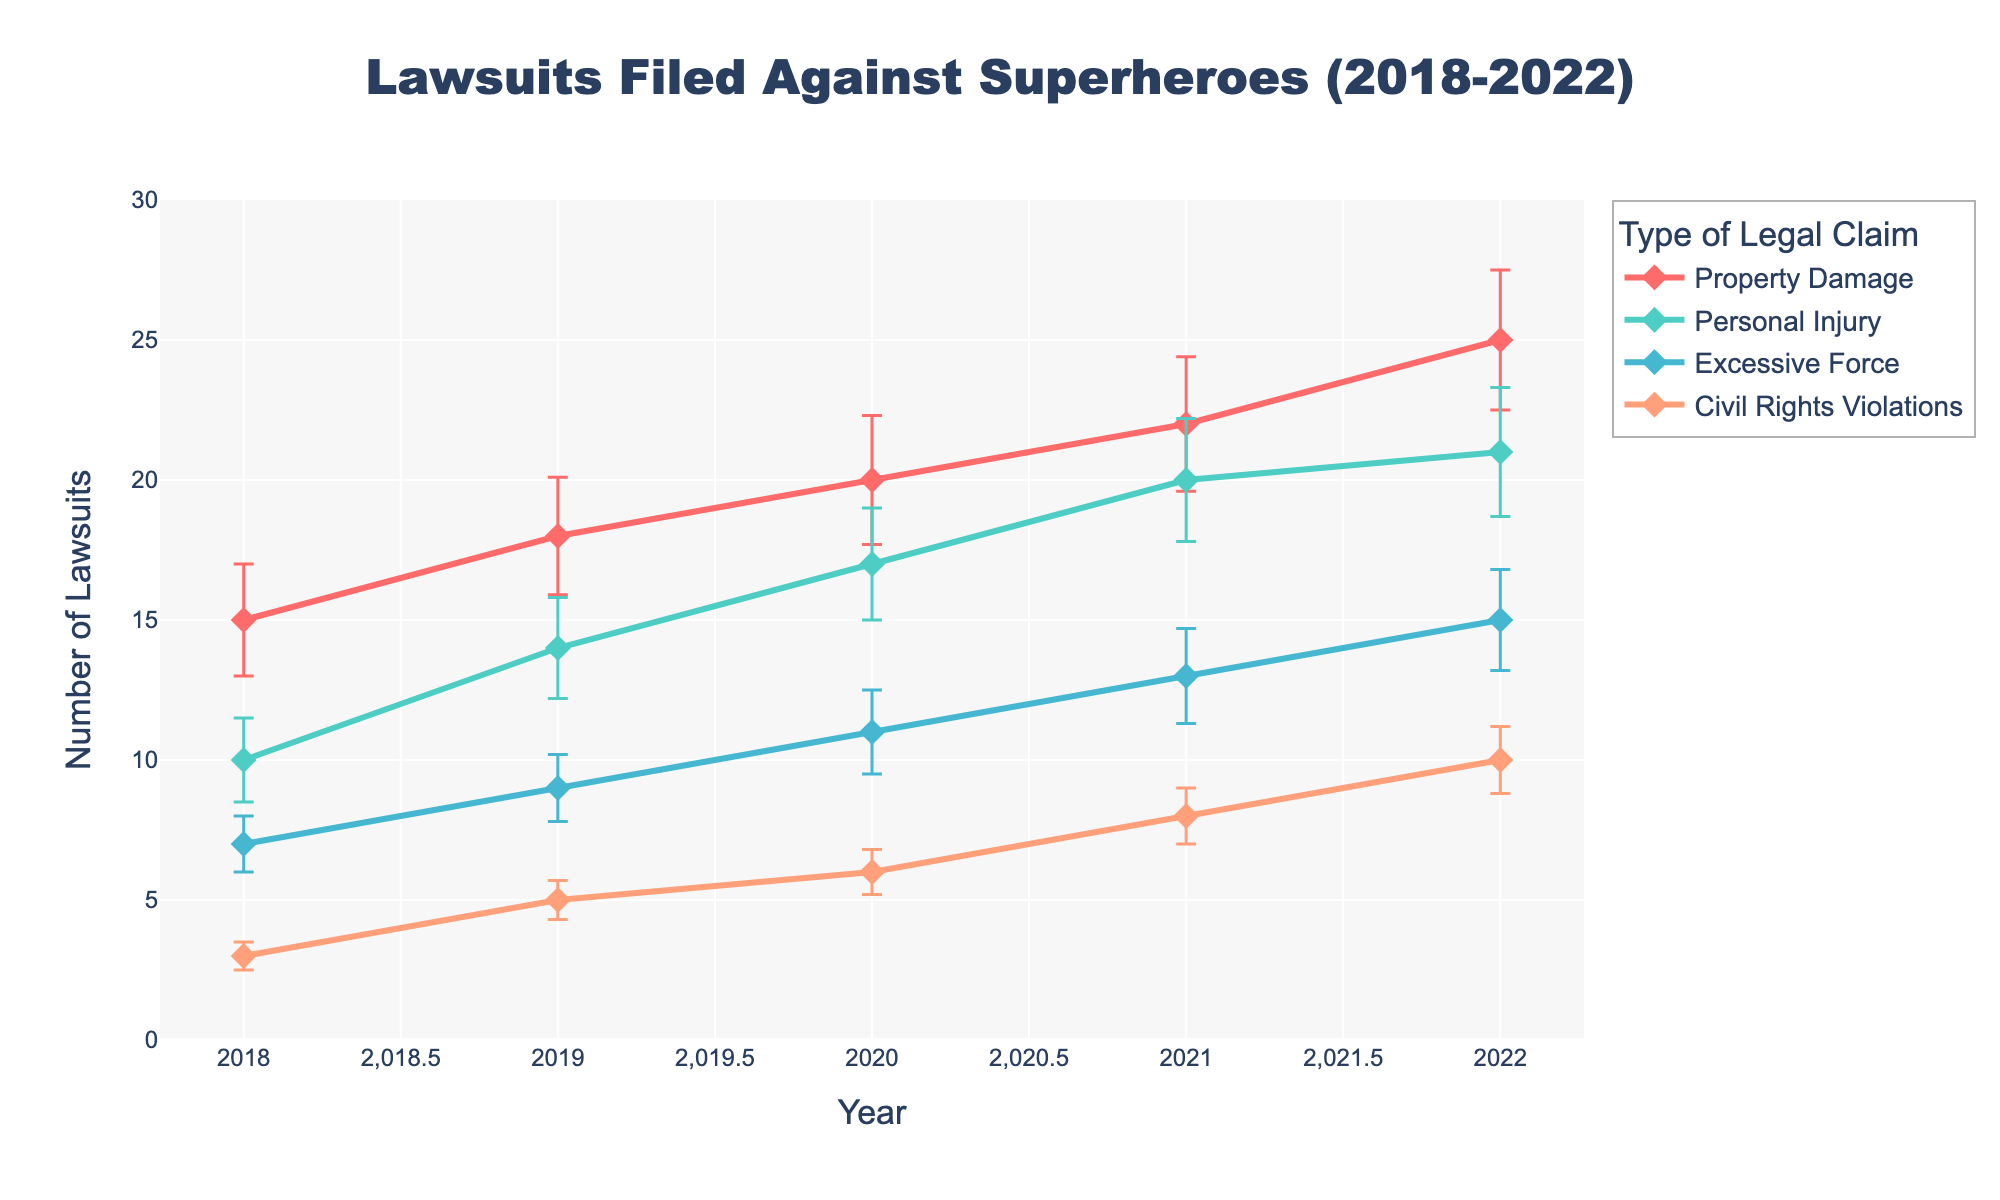What's the title of the figure? The title is displayed at the top of the figure. It provides an overview of what the figure is about. Here, the title reads "Lawsuits Filed Against Superheroes (2018-2022)".
Answer: Lawsuits Filed Against Superheroes (2018-2022) How many types of legal claims are represented in the figure? Each type of legal claim is represented by a distinct colored line with markers, as indicated in the legend. The legend shows four types of legal claims.
Answer: Four Which year saw the highest number of lawsuits filed for Property Damage? The line for Property Damage reaches its highest value in 2022. You can verify this by looking at the y-axis value for Property Damage in 2022, which is higher than in other years.
Answer: 2022 What was the average number of lawsuits filed for Excessive Force over the years 2019 and 2020? To find the average, first add the number of lawsuits for Excessive Force in 2019 (9) and 2020 (11), then divide by 2. So, (9 + 11) / 2 = 10.
Answer: 10 Compare the number of Personal Injury lawsuits filed in 2018 and 2022. Which year had more, and by how much? The number of Personal Injury lawsuits in 2018 is 10, and in 2022 it's 21. To find the difference, subtract 10 from 21, which gives 11.
Answer: 2022, by 11 What is the approximate range of standard errors for Civil Rights Violations in the data? The error bars for Civil Rights Violations give us the range. They start from 0.5 (in 2018) and go up to 1.2 (in 2022). The range can be calculated as 1.2 - 0.5 = 0.7.
Answer: 0.5 to 1.2 Which type of legal claim shows the largest increase in the number of lawsuits filed from 2018 to 2022? Property Damage increases from 15 in 2018 to 25 in 2022. Calculate the difference for each type and compare: Property Damage increases by 10, Personal Injury by 11, Excessive Force by 8, and Civil Rights Violations by 7.
Answer: Personal Injury Are there more or fewer lawsuits filed in 2021 compared to 2020 for Civil Rights Violations? By how many? In 2020, the number of Civil Rights Violations lawsuits is 6, and in 2021, it's 8. To find the difference, subtract 6 from 8, which gives 2.
Answer: More by 2 Which type of legal claim has the smallest standard error in 2022? Looking at the error bars for each type of legal claim in 2022, Civil Rights Violations have the smallest standard error, which is 1.2.
Answer: Civil Rights Violations 